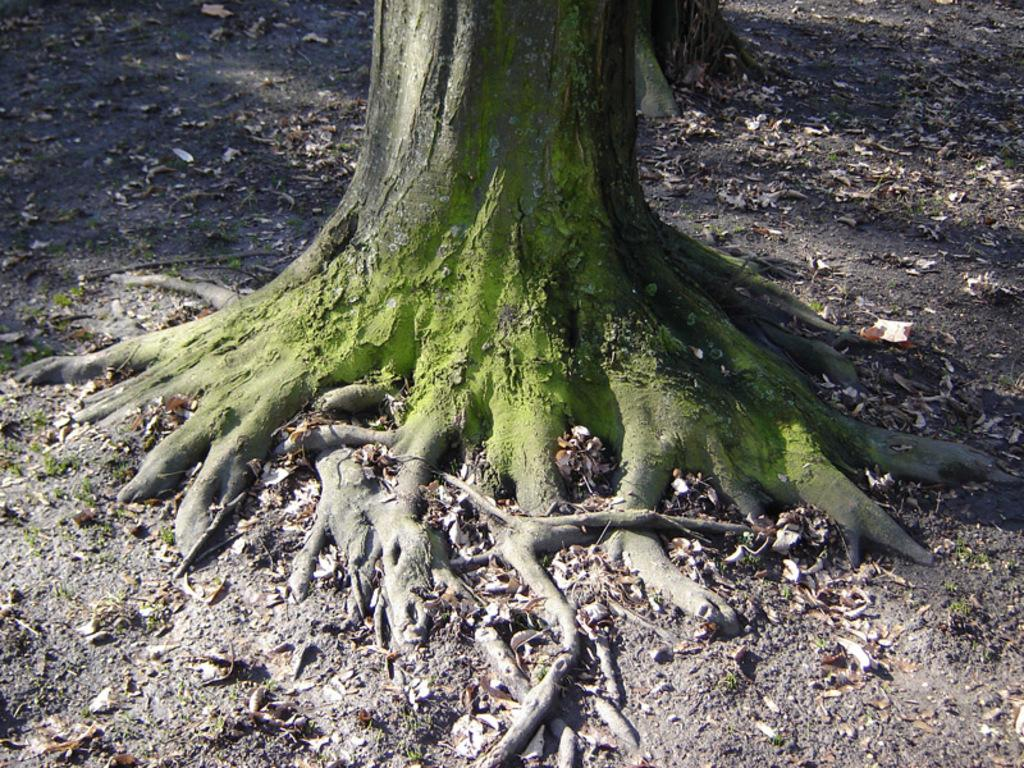What is the main subject of the image? The main subject of the image is a tree trunk. What can be seen on the tree trunk? There is algae on the tree trunk. What part of the tree trunk is visible in the image? The roots are visible at the bottom of the tree trunk. What is present on the ground in the image? Dried leaves and grass are present on the ground. What type of watch is the tree trunk wearing in the image? There is no watch present in the image, as tree trunks do not wear watches. What type of throne is depicted in the image? There is no throne present in the image; it features a tree trunk with algae and roots. 